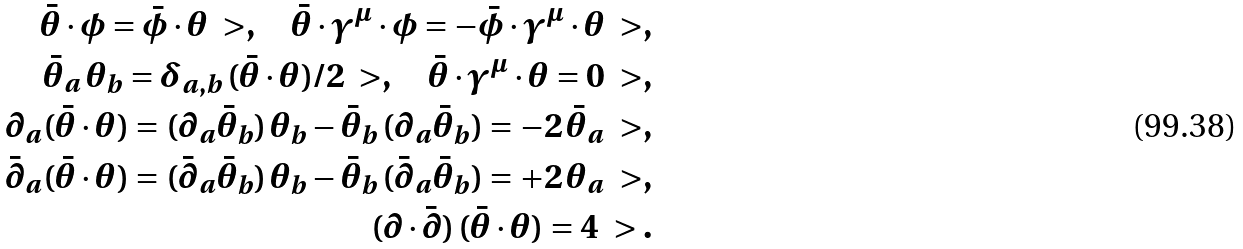Convert formula to latex. <formula><loc_0><loc_0><loc_500><loc_500>\bar { \theta } \cdot \phi = \bar { \phi } \cdot \theta \ > , \quad \bar { \theta } \cdot \gamma ^ { \mu } \cdot \phi = - \bar { \phi } \cdot \gamma ^ { \mu } \cdot \theta \ > , \\ \bar { \theta } _ { a } \, \theta _ { b } = \delta _ { a , b } \, ( \bar { \theta } \cdot \theta ) / 2 \ > , \quad \bar { \theta } \cdot \gamma ^ { \mu } \cdot \theta = 0 \ > , \\ \partial _ { a } ( \bar { \theta } \cdot \theta ) = ( \partial _ { a } \bar { \theta } _ { b } ) \, \theta _ { b } - \bar { \theta } _ { b } \, ( \partial _ { a } \bar { \theta } _ { b } ) = - 2 \, \bar { \theta } _ { a } \ > , \\ \bar { \partial } _ { a } ( \bar { \theta } \cdot \theta ) = ( \bar { \partial } _ { a } \bar { \theta } _ { b } ) \, \theta _ { b } - \bar { \theta } _ { b } \, ( \bar { \partial } _ { a } \bar { \theta } _ { b } ) = + 2 \, \theta _ { a } \ > , \\ ( \partial \cdot \bar { \partial } ) \, ( \bar { \theta } \cdot \theta ) = 4 \ > .</formula> 